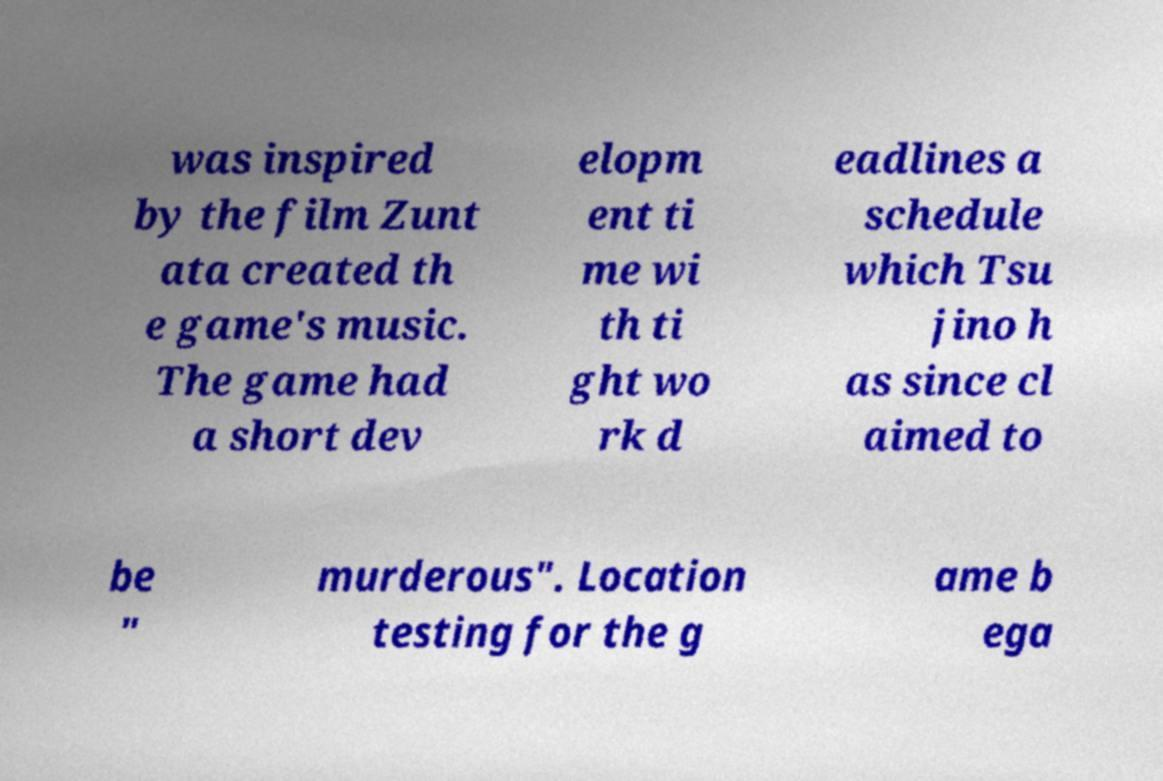Could you assist in decoding the text presented in this image and type it out clearly? was inspired by the film Zunt ata created th e game's music. The game had a short dev elopm ent ti me wi th ti ght wo rk d eadlines a schedule which Tsu jino h as since cl aimed to be " murderous". Location testing for the g ame b ega 